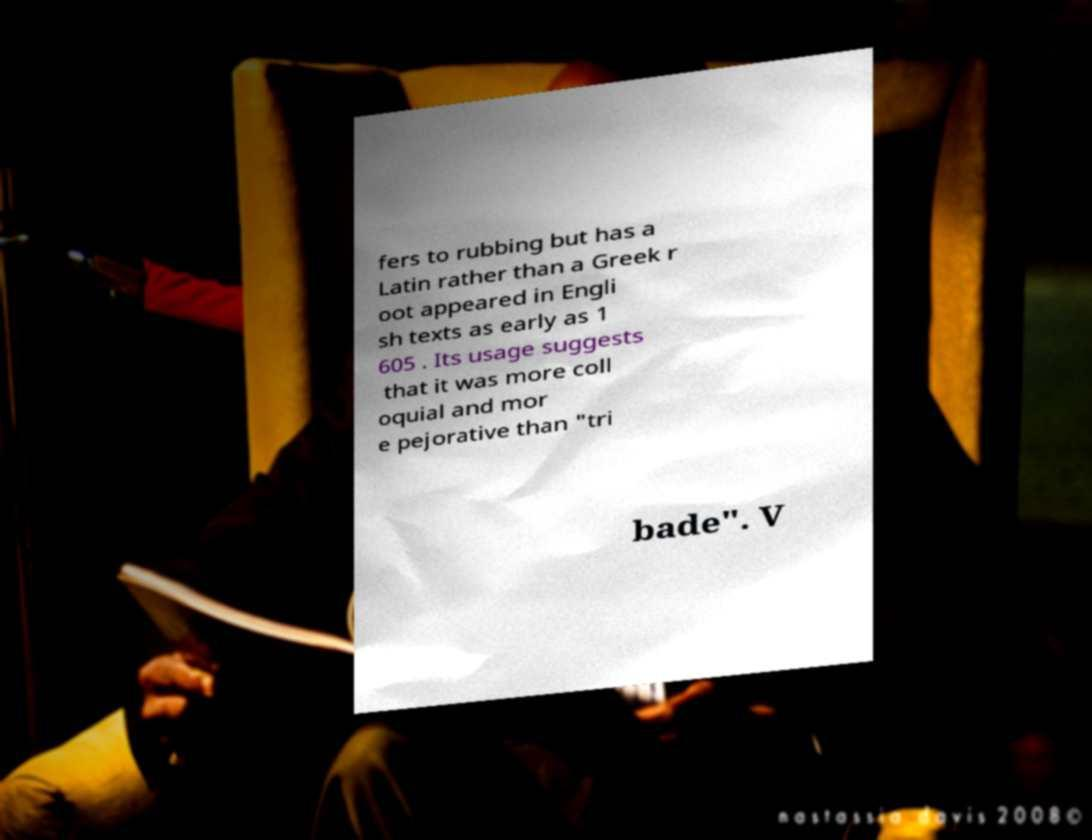Can you accurately transcribe the text from the provided image for me? fers to rubbing but has a Latin rather than a Greek r oot appeared in Engli sh texts as early as 1 605 . Its usage suggests that it was more coll oquial and mor e pejorative than "tri bade". V 